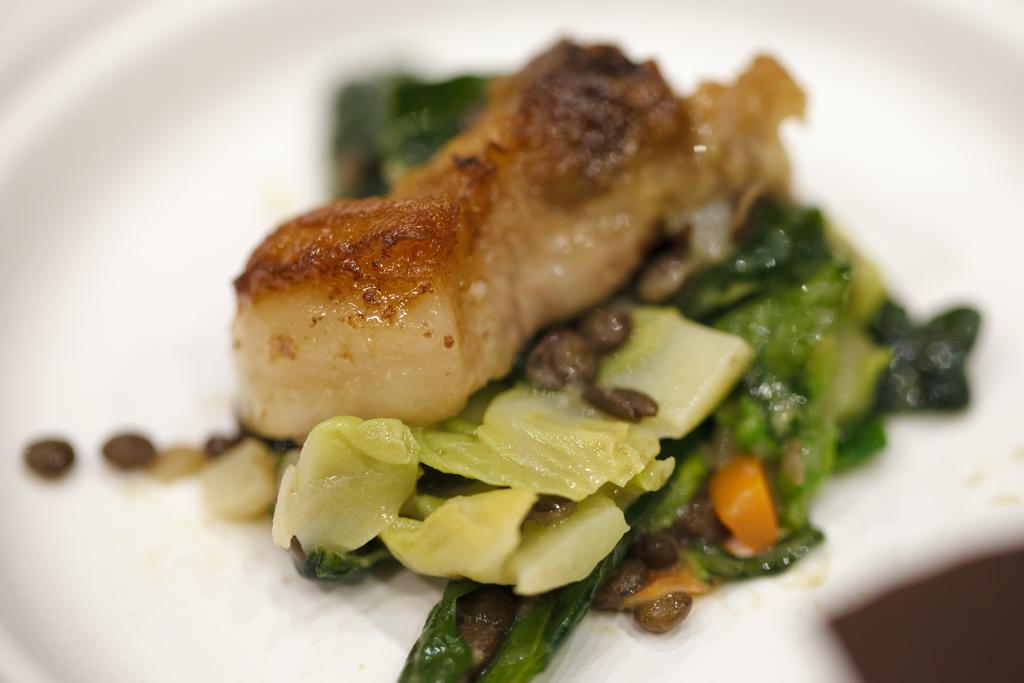What is present in the image related to food? There is food in the image. How is the food arranged or presented? The food is placed on a plate. What is the color of the plate? The plate is white in color. How many eyes can be seen on the food in the image? There are no eyes visible on the food in the image, as eyes are not a characteristic of food items. 